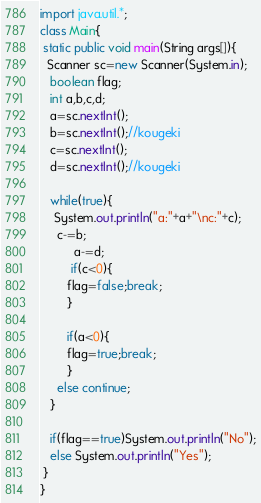Convert code to text. <code><loc_0><loc_0><loc_500><loc_500><_Java_>import java.util.*;
class Main{
 static public void main(String args[]){
  Scanner sc=new Scanner(System.in); 
   boolean flag;
   int a,b,c,d;
   a=sc.nextInt();
   b=sc.nextInt();//kougeki
   c=sc.nextInt();
   d=sc.nextInt();//kougeki
   
   while(true){
   	System.out.println("a:"+a+"\nc:"+c);
     c-=b;
	      a-=d;
	 	 if(c<0){
	 	flag=false;break;
		}

	    if(a<0){
	 	flag=true;break;
		}
	 else continue;
   }
   
   if(flag==true)System.out.println("No");
   else System.out.println("Yes");
 }
}</code> 